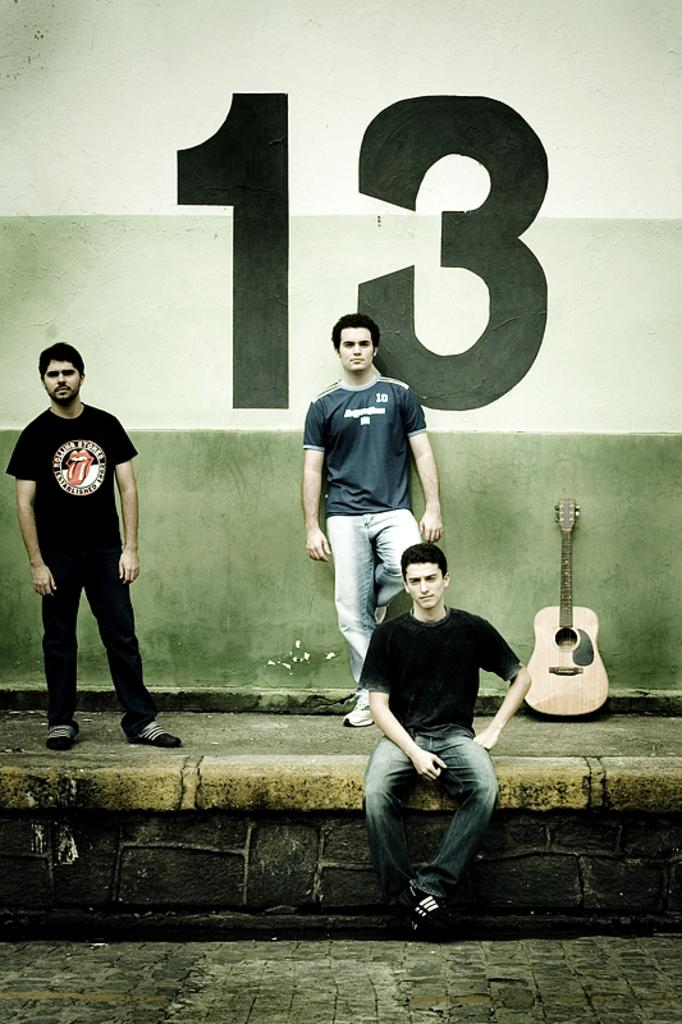What is the person in the image wearing? The person in the image is wearing a black t-shirt. What is the person in the black t-shirt doing? The person is sitting. How many people are standing people can be seen in the background of the image? There are two people standing in the background of the image. What is written on the wall in the background? The number thirteen is painted on the wall in the background. What musical instrument is on the floor in the image? There is a guitar on the floor in the image. What type of tail can be seen on the person in the image? There is no tail visible on the person in the image. What group of people are the two standing individuals a part of in the image? The provided facts do not give any information about the relationship between the two standing individuals or any group they might be a part of. 